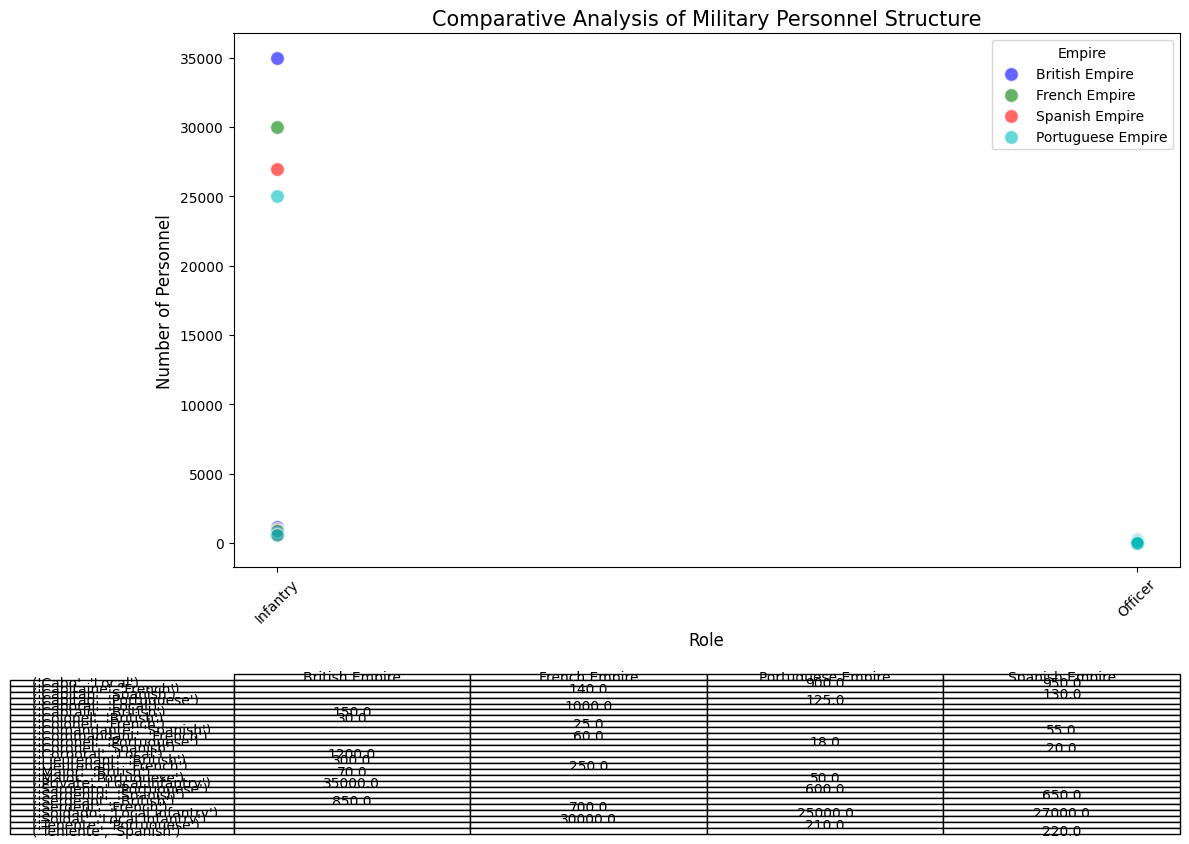Which empire has the highest number of local infantry personnel? According to the figure, the British Empire has the highest number of local infantry personnel with 35,000. This can be immediately identified by the scatter plot where the number of personnel is plotted on the y-axis. The point representing the British Empire at the 'Infantry' role is the highest among all empires.
Answer: British Empire Which role has the least number of personnel in the French Empire? From the scatter plot, we can see that the role with the least number of personnel in the French Empire is 'Colonel' with 25 personnel. By comparing the individual points for the French Empire, it is clear that the 'Colonel' role is the lowest.
Answer: Colonel What is the total number of officers in the Spanish Empire? To find the total number of officers in the Spanish Empire, we sum the numbers for each officer role: Teniente (220), Capitan (130), Comandante (55), and Coronel (20). Adding these: 220 + 130 + 55 + 20 = 425.
Answer: 425 Which empire has more Captains, the British Empire or the Portuguese Empire? To compare the number of Captains between the two empires, we check the scatter plot: The British Empire has 150 Captains and the Portuguese Empire has 125 Captains. This can be seen by looking at the points labeled 'Captain' and comparing their heights.
Answer: British Empire How many more local infantry personnel does the British Empire have compared to the Portuguese Empire? The British Empire has 35,000 local infantry personnel, while the Portuguese Empire has 25,000. Subtracting the two: 35,000 - 25,000 = 10,000.
Answer: 10,000 Which empire's local infantry numbers most closely match those of the French Empire? The French Empire has 30,000 local infantry personnel. By comparing the scatter points, the Spanish Empire has 27,000 which is the closest to 30,000 among the empires.
Answer: Spanish Empire What is the difference in the number of Corporals between the British and Spanish Empires? The British Empire has 1,200 Corporals, and the Spanish Empire has 950 Corporals. Subtracting the two: 1,200 - 950 = 250.
Answer: 250 Which rank has the fewest personnel across all listed empires? By examining the scatter plot's vertical range and the table, the rank of Colonel has the fewest personnel across all listed empires (30 in British, 25 in French, 20 in Spanish, and 18 in Portuguese).
Answer: Colonel 